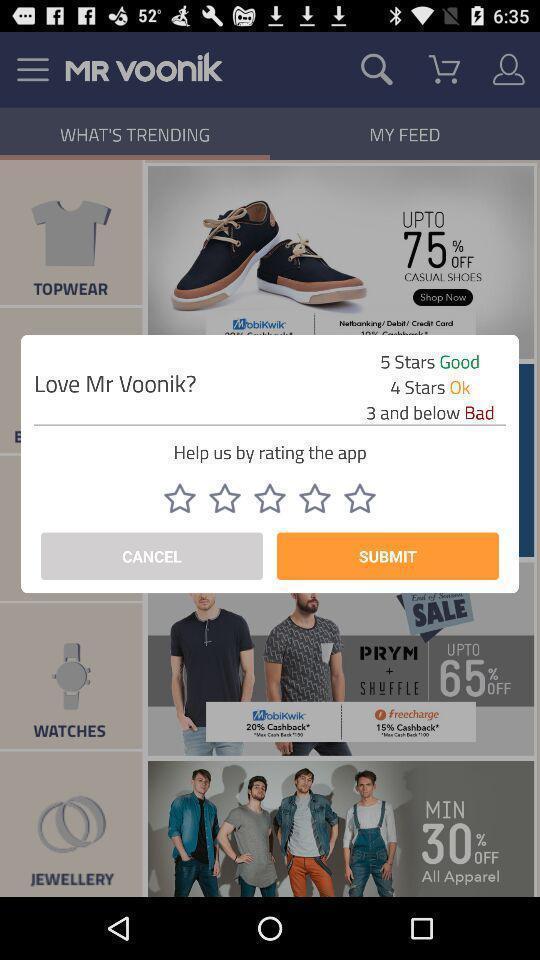What is the overall content of this screenshot? Rating pop up of an online shopping app. 